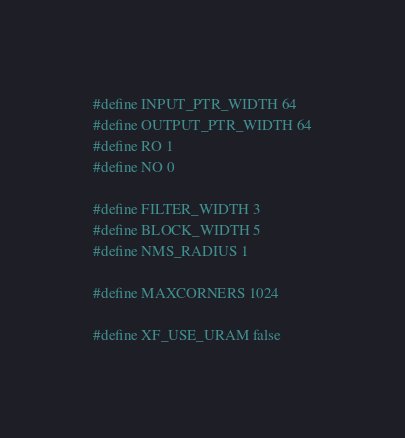<code> <loc_0><loc_0><loc_500><loc_500><_C_>#define INPUT_PTR_WIDTH 64
#define OUTPUT_PTR_WIDTH 64
#define RO 1
#define NO 0

#define FILTER_WIDTH 3
#define BLOCK_WIDTH 5
#define NMS_RADIUS 1

#define MAXCORNERS 1024

#define XF_USE_URAM false
</code> 